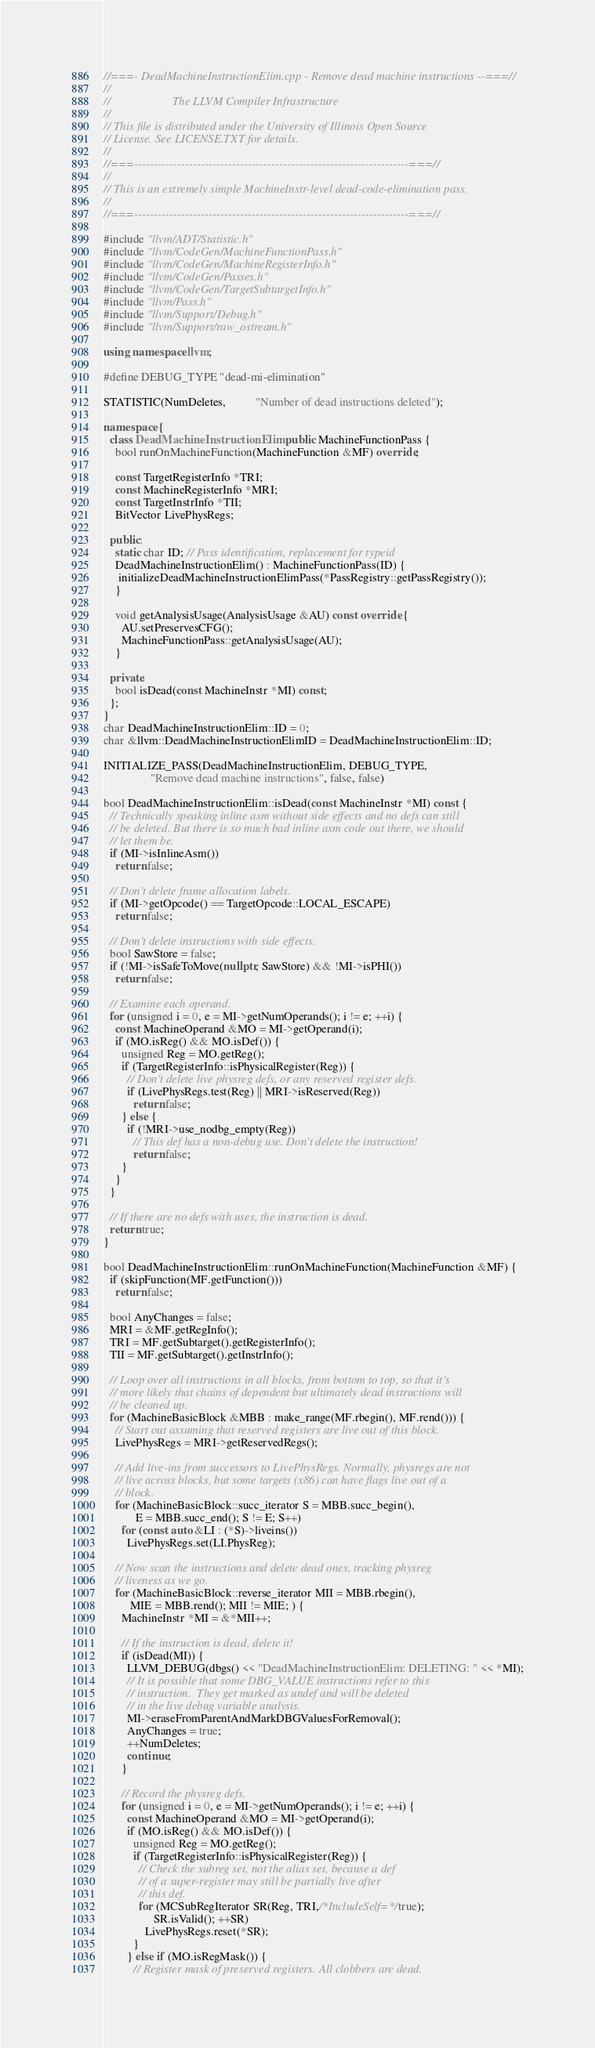Convert code to text. <code><loc_0><loc_0><loc_500><loc_500><_C++_>//===- DeadMachineInstructionElim.cpp - Remove dead machine instructions --===//
//
//                     The LLVM Compiler Infrastructure
//
// This file is distributed under the University of Illinois Open Source
// License. See LICENSE.TXT for details.
//
//===----------------------------------------------------------------------===//
//
// This is an extremely simple MachineInstr-level dead-code-elimination pass.
//
//===----------------------------------------------------------------------===//

#include "llvm/ADT/Statistic.h"
#include "llvm/CodeGen/MachineFunctionPass.h"
#include "llvm/CodeGen/MachineRegisterInfo.h"
#include "llvm/CodeGen/Passes.h"
#include "llvm/CodeGen/TargetSubtargetInfo.h"
#include "llvm/Pass.h"
#include "llvm/Support/Debug.h"
#include "llvm/Support/raw_ostream.h"

using namespace llvm;

#define DEBUG_TYPE "dead-mi-elimination"

STATISTIC(NumDeletes,          "Number of dead instructions deleted");

namespace {
  class DeadMachineInstructionElim : public MachineFunctionPass {
    bool runOnMachineFunction(MachineFunction &MF) override;

    const TargetRegisterInfo *TRI;
    const MachineRegisterInfo *MRI;
    const TargetInstrInfo *TII;
    BitVector LivePhysRegs;

  public:
    static char ID; // Pass identification, replacement for typeid
    DeadMachineInstructionElim() : MachineFunctionPass(ID) {
     initializeDeadMachineInstructionElimPass(*PassRegistry::getPassRegistry());
    }

    void getAnalysisUsage(AnalysisUsage &AU) const override {
      AU.setPreservesCFG();
      MachineFunctionPass::getAnalysisUsage(AU);
    }

  private:
    bool isDead(const MachineInstr *MI) const;
  };
}
char DeadMachineInstructionElim::ID = 0;
char &llvm::DeadMachineInstructionElimID = DeadMachineInstructionElim::ID;

INITIALIZE_PASS(DeadMachineInstructionElim, DEBUG_TYPE,
                "Remove dead machine instructions", false, false)

bool DeadMachineInstructionElim::isDead(const MachineInstr *MI) const {
  // Technically speaking inline asm without side effects and no defs can still
  // be deleted. But there is so much bad inline asm code out there, we should
  // let them be.
  if (MI->isInlineAsm())
    return false;

  // Don't delete frame allocation labels.
  if (MI->getOpcode() == TargetOpcode::LOCAL_ESCAPE)
    return false;

  // Don't delete instructions with side effects.
  bool SawStore = false;
  if (!MI->isSafeToMove(nullptr, SawStore) && !MI->isPHI())
    return false;

  // Examine each operand.
  for (unsigned i = 0, e = MI->getNumOperands(); i != e; ++i) {
    const MachineOperand &MO = MI->getOperand(i);
    if (MO.isReg() && MO.isDef()) {
      unsigned Reg = MO.getReg();
      if (TargetRegisterInfo::isPhysicalRegister(Reg)) {
        // Don't delete live physreg defs, or any reserved register defs.
        if (LivePhysRegs.test(Reg) || MRI->isReserved(Reg))
          return false;
      } else {
        if (!MRI->use_nodbg_empty(Reg))
          // This def has a non-debug use. Don't delete the instruction!
          return false;
      }
    }
  }

  // If there are no defs with uses, the instruction is dead.
  return true;
}

bool DeadMachineInstructionElim::runOnMachineFunction(MachineFunction &MF) {
  if (skipFunction(MF.getFunction()))
    return false;

  bool AnyChanges = false;
  MRI = &MF.getRegInfo();
  TRI = MF.getSubtarget().getRegisterInfo();
  TII = MF.getSubtarget().getInstrInfo();

  // Loop over all instructions in all blocks, from bottom to top, so that it's
  // more likely that chains of dependent but ultimately dead instructions will
  // be cleaned up.
  for (MachineBasicBlock &MBB : make_range(MF.rbegin(), MF.rend())) {
    // Start out assuming that reserved registers are live out of this block.
    LivePhysRegs = MRI->getReservedRegs();

    // Add live-ins from successors to LivePhysRegs. Normally, physregs are not
    // live across blocks, but some targets (x86) can have flags live out of a
    // block.
    for (MachineBasicBlock::succ_iterator S = MBB.succ_begin(),
           E = MBB.succ_end(); S != E; S++)
      for (const auto &LI : (*S)->liveins())
        LivePhysRegs.set(LI.PhysReg);

    // Now scan the instructions and delete dead ones, tracking physreg
    // liveness as we go.
    for (MachineBasicBlock::reverse_iterator MII = MBB.rbegin(),
         MIE = MBB.rend(); MII != MIE; ) {
      MachineInstr *MI = &*MII++;

      // If the instruction is dead, delete it!
      if (isDead(MI)) {
        LLVM_DEBUG(dbgs() << "DeadMachineInstructionElim: DELETING: " << *MI);
        // It is possible that some DBG_VALUE instructions refer to this
        // instruction.  They get marked as undef and will be deleted
        // in the live debug variable analysis.
        MI->eraseFromParentAndMarkDBGValuesForRemoval();
        AnyChanges = true;
        ++NumDeletes;
        continue;
      }

      // Record the physreg defs.
      for (unsigned i = 0, e = MI->getNumOperands(); i != e; ++i) {
        const MachineOperand &MO = MI->getOperand(i);
        if (MO.isReg() && MO.isDef()) {
          unsigned Reg = MO.getReg();
          if (TargetRegisterInfo::isPhysicalRegister(Reg)) {
            // Check the subreg set, not the alias set, because a def
            // of a super-register may still be partially live after
            // this def.
            for (MCSubRegIterator SR(Reg, TRI,/*IncludeSelf=*/true);
                 SR.isValid(); ++SR)
              LivePhysRegs.reset(*SR);
          }
        } else if (MO.isRegMask()) {
          // Register mask of preserved registers. All clobbers are dead.</code> 